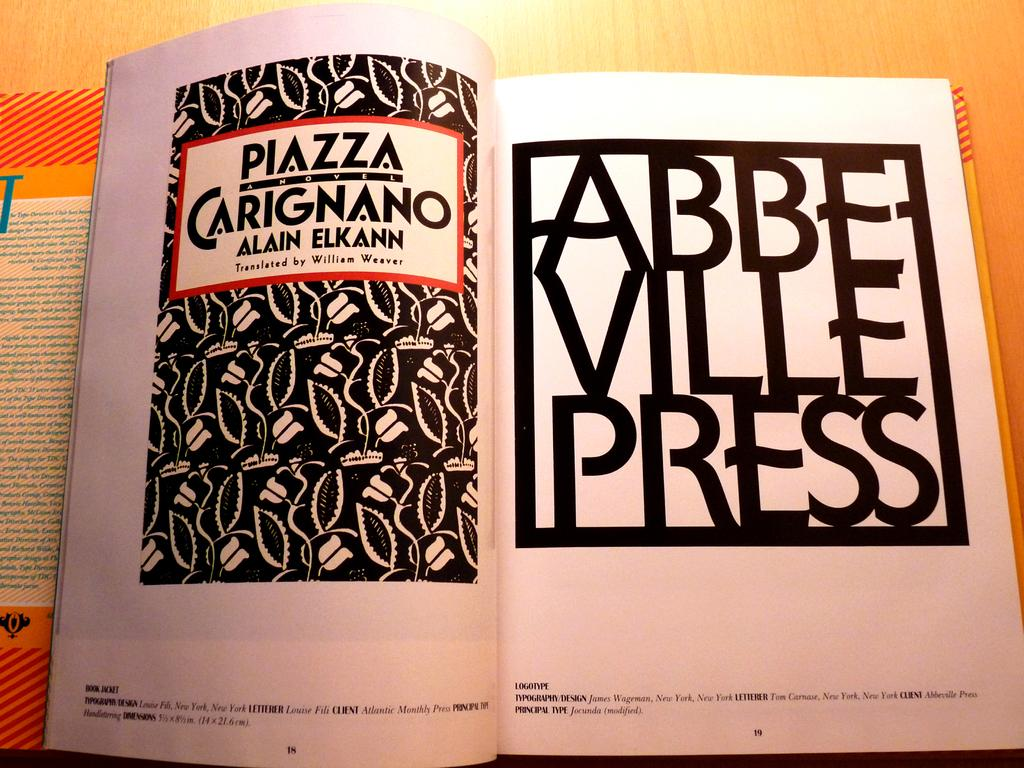<image>
Describe the image concisely. A book open to the title page showing what press made it 